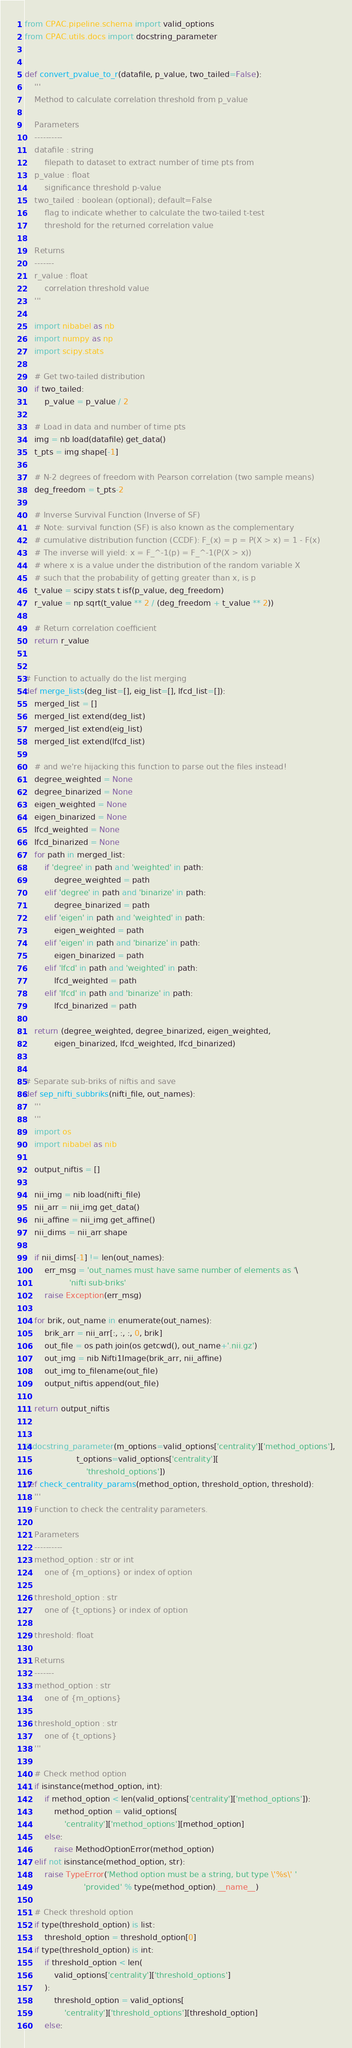Convert code to text. <code><loc_0><loc_0><loc_500><loc_500><_Python_>from CPAC.pipeline.schema import valid_options
from CPAC.utils.docs import docstring_parameter


def convert_pvalue_to_r(datafile, p_value, two_tailed=False):
    '''
    Method to calculate correlation threshold from p_value

    Parameters
    ----------
    datafile : string
        filepath to dataset to extract number of time pts from
    p_value : float
        significance threshold p-value
    two_tailed : boolean (optional); default=False
        flag to indicate whether to calculate the two-tailed t-test
        threshold for the returned correlation value

    Returns
    -------
    r_value : float
        correlation threshold value
    '''

    import nibabel as nb
    import numpy as np
    import scipy.stats

    # Get two-tailed distribution
    if two_tailed:
        p_value = p_value / 2

    # Load in data and number of time pts
    img = nb.load(datafile).get_data()
    t_pts = img.shape[-1]

    # N-2 degrees of freedom with Pearson correlation (two sample means)
    deg_freedom = t_pts-2

    # Inverse Survival Function (Inverse of SF)
    # Note: survival function (SF) is also known as the complementary
    # cumulative distribution function (CCDF): F_(x) = p = P(X > x) = 1 - F(x)
    # The inverse will yield: x = F_^-1(p) = F_^-1(P(X > x))
    # where x is a value under the distribution of the random variable X
    # such that the probability of getting greater than x, is p
    t_value = scipy.stats.t.isf(p_value, deg_freedom)
    r_value = np.sqrt(t_value ** 2 / (deg_freedom + t_value ** 2))

    # Return correlation coefficient
    return r_value


# Function to actually do the list merging
def merge_lists(deg_list=[], eig_list=[], lfcd_list=[]):
    merged_list = []
    merged_list.extend(deg_list)
    merged_list.extend(eig_list)
    merged_list.extend(lfcd_list)

    # and we're hijacking this function to parse out the files instead!
    degree_weighted = None
    degree_binarized = None
    eigen_weighted = None
    eigen_binarized = None
    lfcd_weighted = None
    lfcd_binarized = None
    for path in merged_list:
        if 'degree' in path and 'weighted' in path:
            degree_weighted = path
        elif 'degree' in path and 'binarize' in path:
            degree_binarized = path
        elif 'eigen' in path and 'weighted' in path:
            eigen_weighted = path
        elif 'eigen' in path and 'binarize' in path:
            eigen_binarized = path
        elif 'lfcd' in path and 'weighted' in path:
            lfcd_weighted = path
        elif 'lfcd' in path and 'binarize' in path:
            lfcd_binarized = path

    return (degree_weighted, degree_binarized, eigen_weighted,
            eigen_binarized, lfcd_weighted, lfcd_binarized)


# Separate sub-briks of niftis and save
def sep_nifti_subbriks(nifti_file, out_names):
    '''
    '''
    import os
    import nibabel as nib

    output_niftis = []

    nii_img = nib.load(nifti_file)
    nii_arr = nii_img.get_data()
    nii_affine = nii_img.get_affine()
    nii_dims = nii_arr.shape

    if nii_dims[-1] != len(out_names):
        err_msg = 'out_names must have same number of elements as '\
                  'nifti sub-briks'
        raise Exception(err_msg)

    for brik, out_name in enumerate(out_names):
        brik_arr = nii_arr[:, :, :, 0, brik]
        out_file = os.path.join(os.getcwd(), out_name+'.nii.gz')
        out_img = nib.Nifti1Image(brik_arr, nii_affine)
        out_img.to_filename(out_file)
        output_niftis.append(out_file)

    return output_niftis


@docstring_parameter(m_options=valid_options['centrality']['method_options'],
                     t_options=valid_options['centrality'][
                         'threshold_options'])
def check_centrality_params(method_option, threshold_option, threshold):
    '''
    Function to check the centrality parameters.

    Parameters
    ----------
    method_option : str or int
        one of {m_options} or index of option

    threshold_option : str
        one of {t_options} or index of option

    threshold: float

    Returns
    -------
    method_option : str
        one of {m_options}

    threshold_option : str
        one of {t_options}
    '''

    # Check method option
    if isinstance(method_option, int):
        if method_option < len(valid_options['centrality']['method_options']):
            method_option = valid_options[
                'centrality']['method_options'][method_option]
        else:
            raise MethodOptionError(method_option)
    elif not isinstance(method_option, str):
        raise TypeError('Method option must be a string, but type \'%s\' '
                        'provided' % type(method_option).__name__)

    # Check threshold option
    if type(threshold_option) is list:
        threshold_option = threshold_option[0]
    if type(threshold_option) is int:
        if threshold_option < len(
            valid_options['centrality']['threshold_options']
        ):
            threshold_option = valid_options[
                'centrality']['threshold_options'][threshold_option]
        else:</code> 